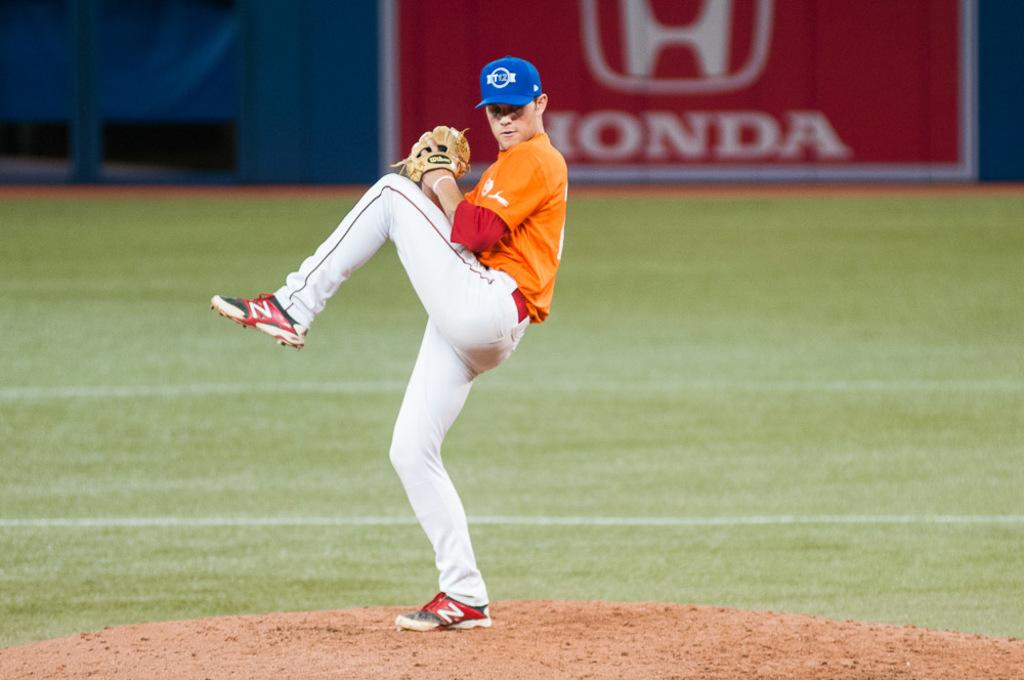<image>
Relay a brief, clear account of the picture shown. A baseball pitcher in front of an advert for Honda. 